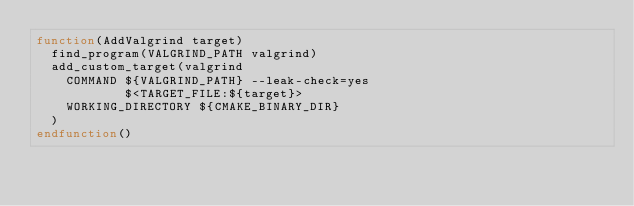<code> <loc_0><loc_0><loc_500><loc_500><_CMake_>function(AddValgrind target)
  find_program(VALGRIND_PATH valgrind)
  add_custom_target(valgrind
    COMMAND ${VALGRIND_PATH} --leak-check=yes
            $<TARGET_FILE:${target}>
    WORKING_DIRECTORY ${CMAKE_BINARY_DIR}
  )
endfunction()
</code> 